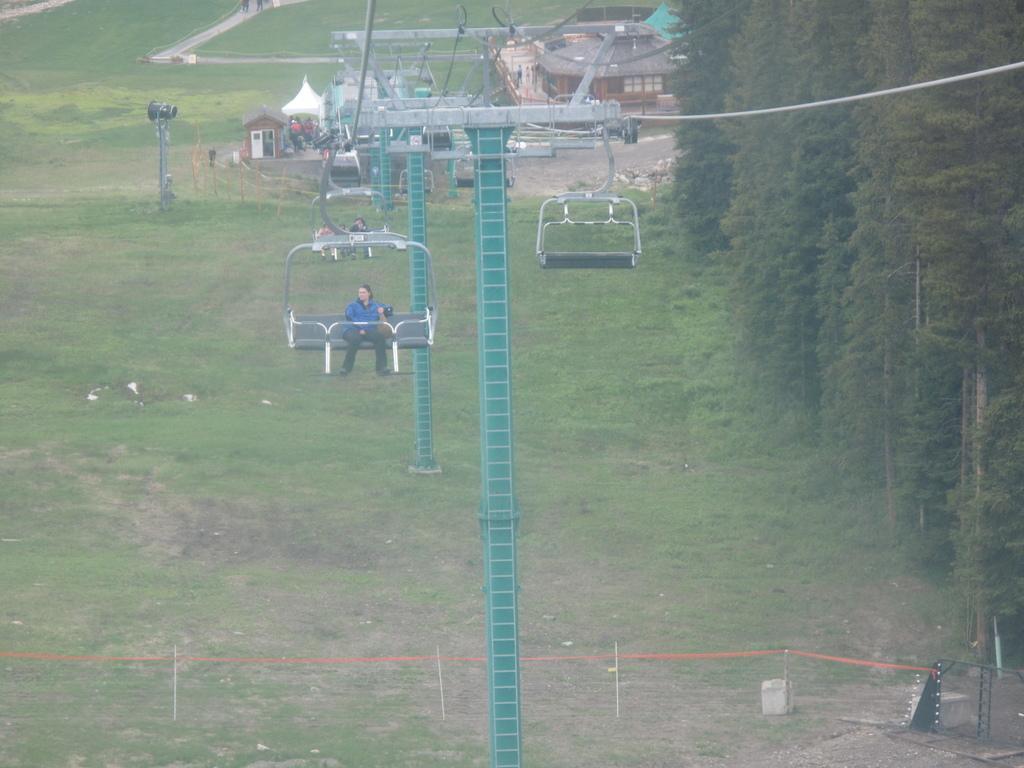How would you summarize this image in a sentence or two? In this picture we can see people sitting on a cable car & at the bottom we have grass and green trees. At the top we can see poles & ropes. 